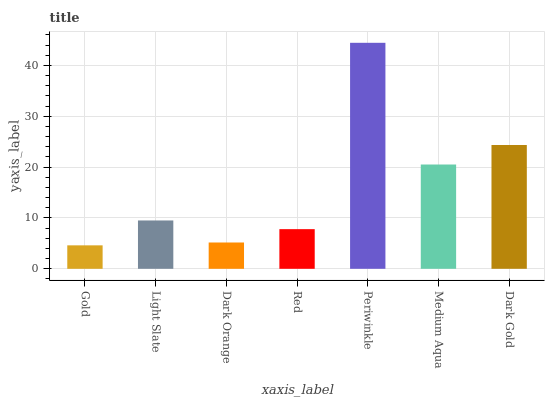Is Gold the minimum?
Answer yes or no. Yes. Is Periwinkle the maximum?
Answer yes or no. Yes. Is Light Slate the minimum?
Answer yes or no. No. Is Light Slate the maximum?
Answer yes or no. No. Is Light Slate greater than Gold?
Answer yes or no. Yes. Is Gold less than Light Slate?
Answer yes or no. Yes. Is Gold greater than Light Slate?
Answer yes or no. No. Is Light Slate less than Gold?
Answer yes or no. No. Is Light Slate the high median?
Answer yes or no. Yes. Is Light Slate the low median?
Answer yes or no. Yes. Is Dark Gold the high median?
Answer yes or no. No. Is Gold the low median?
Answer yes or no. No. 